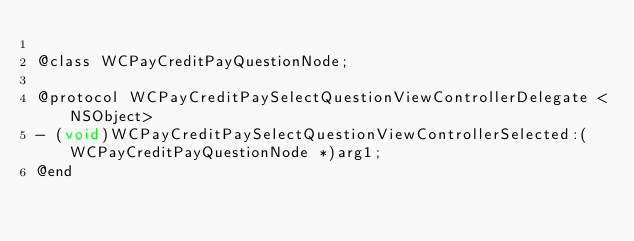Convert code to text. <code><loc_0><loc_0><loc_500><loc_500><_C_>
@class WCPayCreditPayQuestionNode;

@protocol WCPayCreditPaySelectQuestionViewControllerDelegate <NSObject>
- (void)WCPayCreditPaySelectQuestionViewControllerSelected:(WCPayCreditPayQuestionNode *)arg1;
@end

</code> 